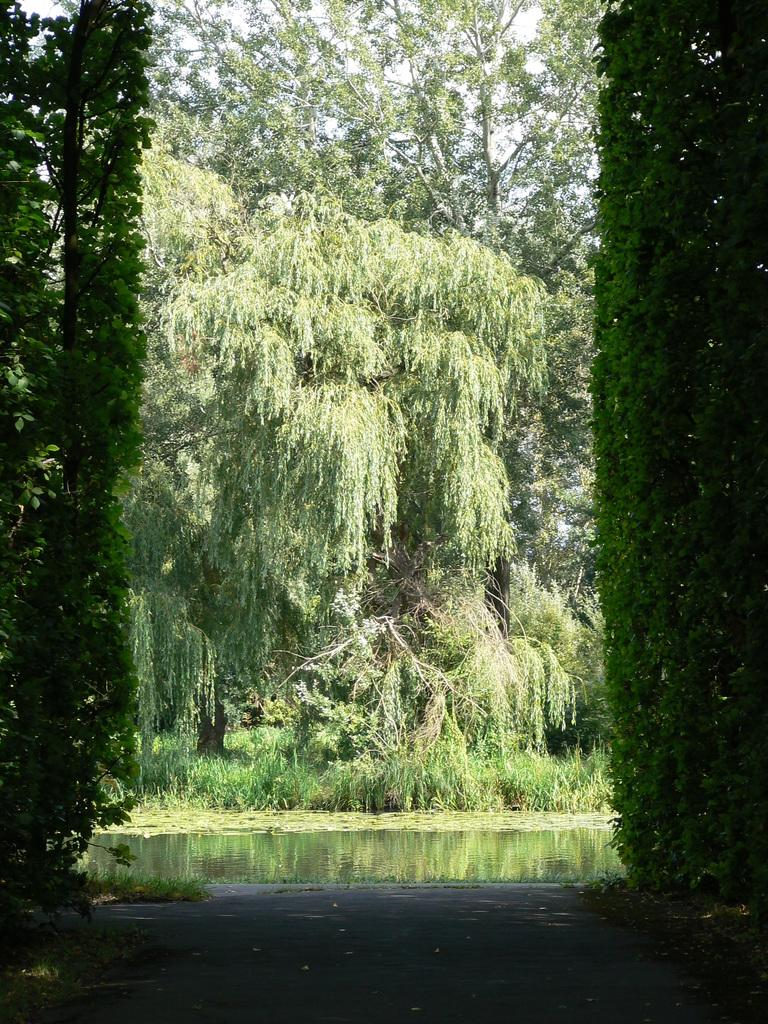What is one of the main elements in the picture? There is water in the picture. What type of vegetation can be seen in the picture? There are trees in the picture. How would you describe the sky in the picture? The sky is clear in the picture. Where is the church located in the picture? There is no church present in the picture; it only features water, trees, and a clear sky. What type of bread can be seen floating on the water in the picture? There is no bread present in the picture; it only features water, trees, and a clear sky. 